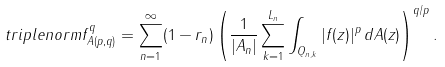<formula> <loc_0><loc_0><loc_500><loc_500>\ t r i p l e n o r m { f } ^ { q } _ { A ( p , q ) } = \sum _ { n = 1 } ^ { \infty } ( 1 - r _ { n } ) \left ( \frac { 1 } { | A _ { n } | } \sum _ { k = 1 } ^ { L _ { n } } \int _ { Q _ { n , k } } | f ( z ) | ^ { p } \, d A ( z ) \right ) ^ { q / p } .</formula> 